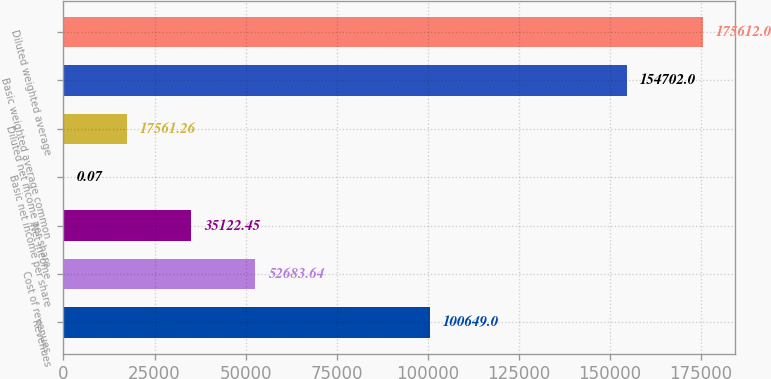Convert chart. <chart><loc_0><loc_0><loc_500><loc_500><bar_chart><fcel>Revenues<fcel>Cost of revenues<fcel>Net income<fcel>Basic net income per share<fcel>Diluted net income per share<fcel>Basic weighted average common<fcel>Diluted weighted average<nl><fcel>100649<fcel>52683.6<fcel>35122.4<fcel>0.07<fcel>17561.3<fcel>154702<fcel>175612<nl></chart> 